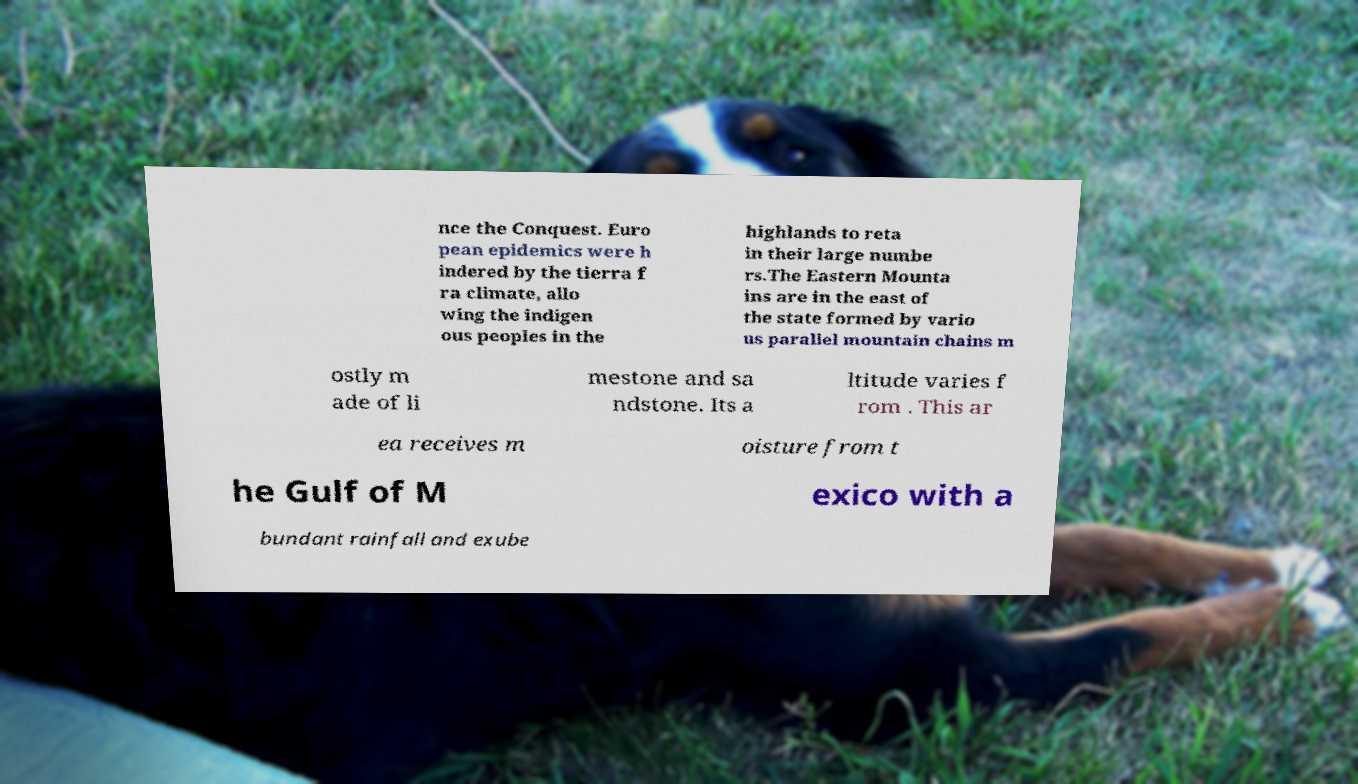I need the written content from this picture converted into text. Can you do that? nce the Conquest. Euro pean epidemics were h indered by the tierra f ra climate, allo wing the indigen ous peoples in the highlands to reta in their large numbe rs.The Eastern Mounta ins are in the east of the state formed by vario us parallel mountain chains m ostly m ade of li mestone and sa ndstone. Its a ltitude varies f rom . This ar ea receives m oisture from t he Gulf of M exico with a bundant rainfall and exube 